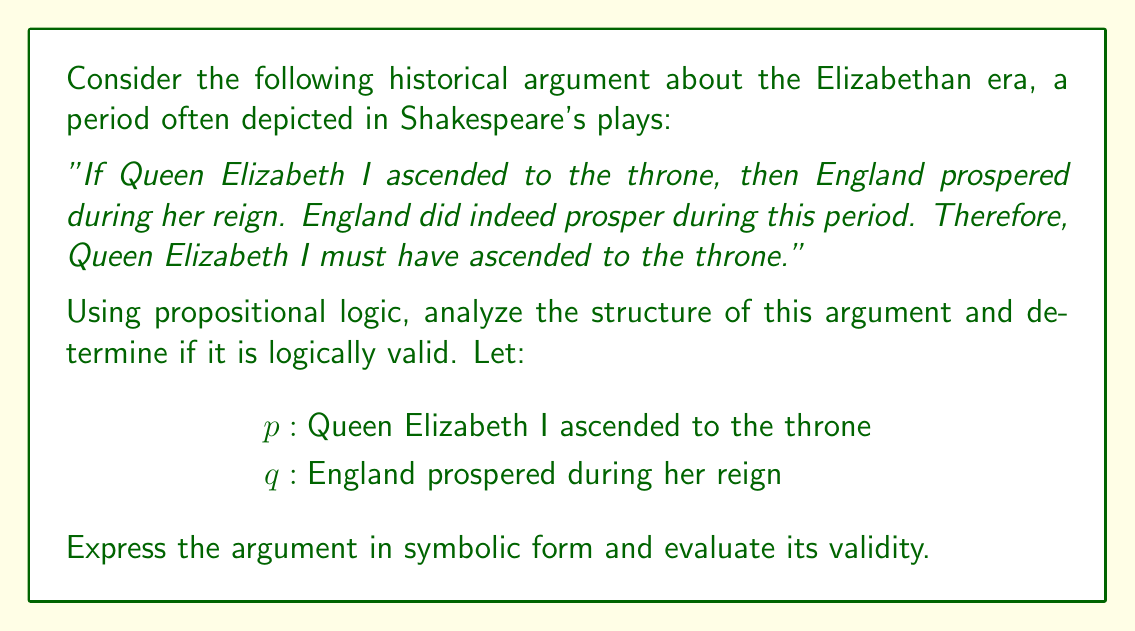Help me with this question. Let's analyze this argument step-by-step using propositional logic:

1) First, we need to identify the premises and conclusion:
   Premise 1: If Queen Elizabeth I ascended to the throne, then England prospered during her reign.
   Premise 2: England did indeed prosper during this period.
   Conclusion: Therefore, Queen Elizabeth I must have ascended to the throne.

2) Now, let's express these in symbolic form:
   Premise 1: $p \rightarrow q$
   Premise 2: $q$
   Conclusion: $\therefore p$

3) The structure of this argument is:
   $$(p \rightarrow q) \land q \therefore p$$

4) This form of argument is known as the fallacy of affirming the consequent. It's not logically valid because it incorrectly assumes that if the consequent ($q$) is true, then the antecedent ($p$) must also be true.

5) To illustrate why this is invalid, consider the following truth table:

   $$\begin{array}{|c|c|c|}
   \hline
   p & q & p \rightarrow q \\
   \hline
   T & T & T \\
   T & F & F \\
   F & T & T \\
   F & F & T \\
   \hline
   \end{array}$$

6) As we can see, it's possible for $q$ to be true (England prospered) even when $p$ is false (Elizabeth didn't ascend to the throne). Therefore, we cannot conclude $p$ from $(p \rightarrow q)$ and $q$ alone.

7) For an argument to be valid, it must be impossible for the premises to be true and the conclusion false. In this case, it is possible for the premises to be true (Elizabeth's ascension led to prosperity, and England did prosper) while the conclusion is false (Elizabeth didn't actually ascend).

Therefore, this historical argument, while perhaps persuasive, is not logically valid according to the rules of propositional logic.
Answer: The argument is invalid; it commits the fallacy of affirming the consequent. 